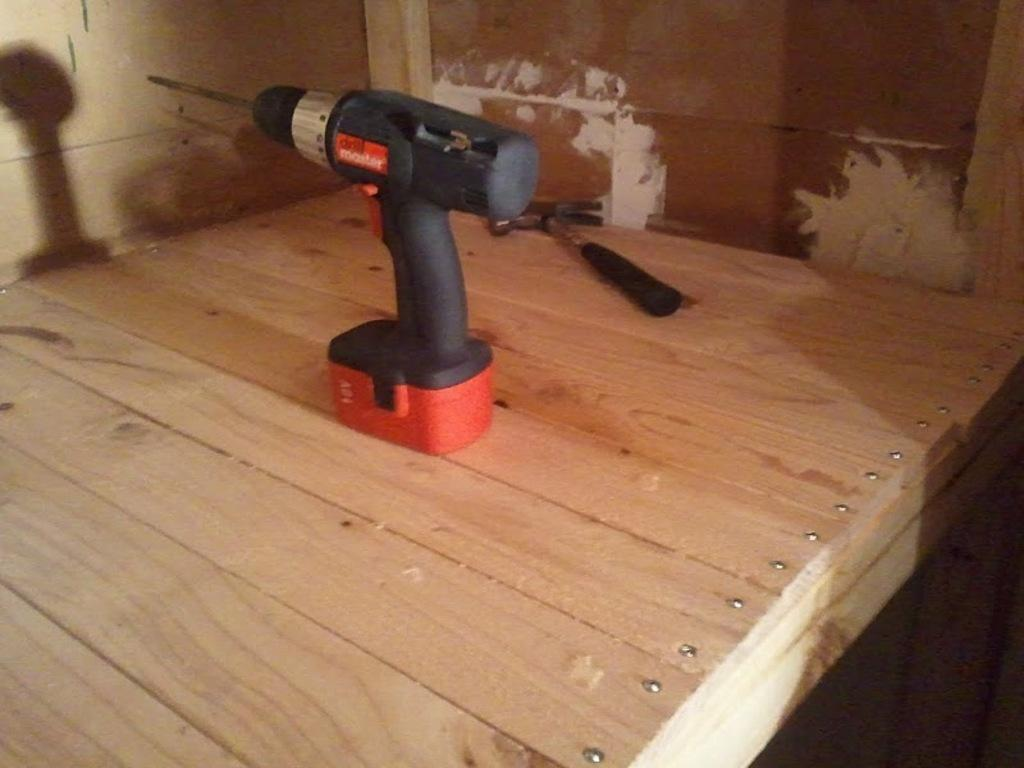What is located in the middle of the image? There is a table in the middle of the image. What can be seen on the table? There are products on the table. What is visible at the top of the image? There is a wall visible at the top of the image. Can you see a bear sitting on the table in the image? No, there is no bear present in the image. What type of window can be seen in the image? There is no window visible in the image; only a table, products, and a wall are present. 